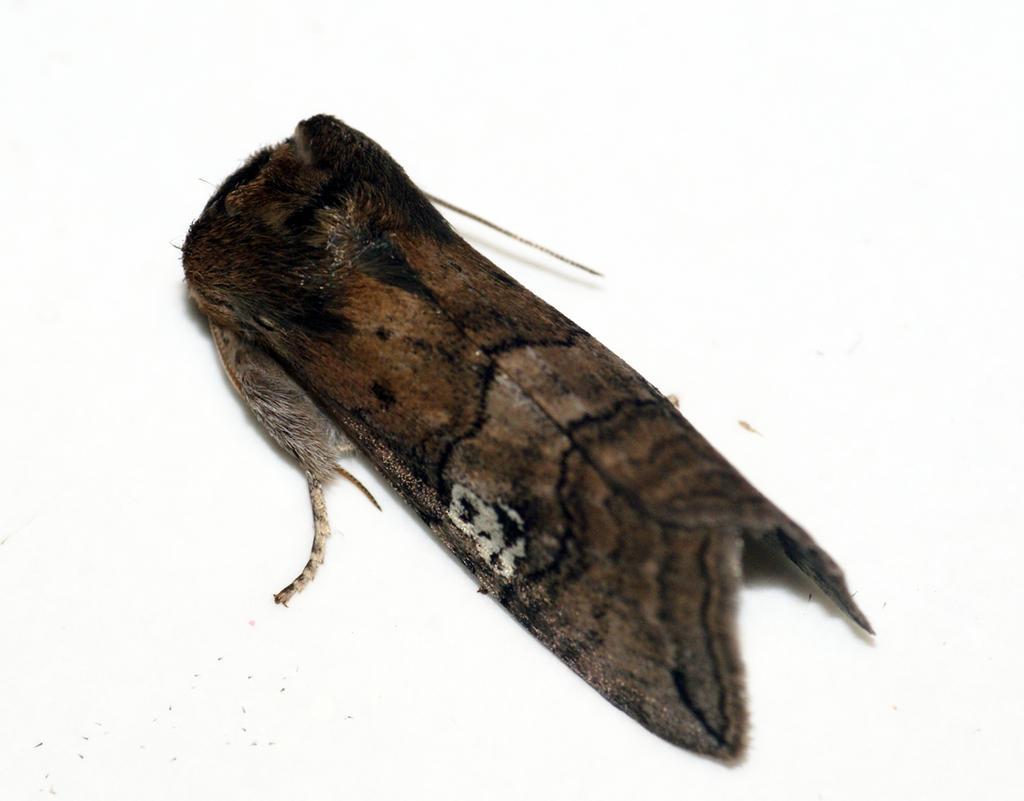Could you give a brief overview of what you see in this image? In this image I can see a insect which is brown, black and white in color on the white colored surface. 